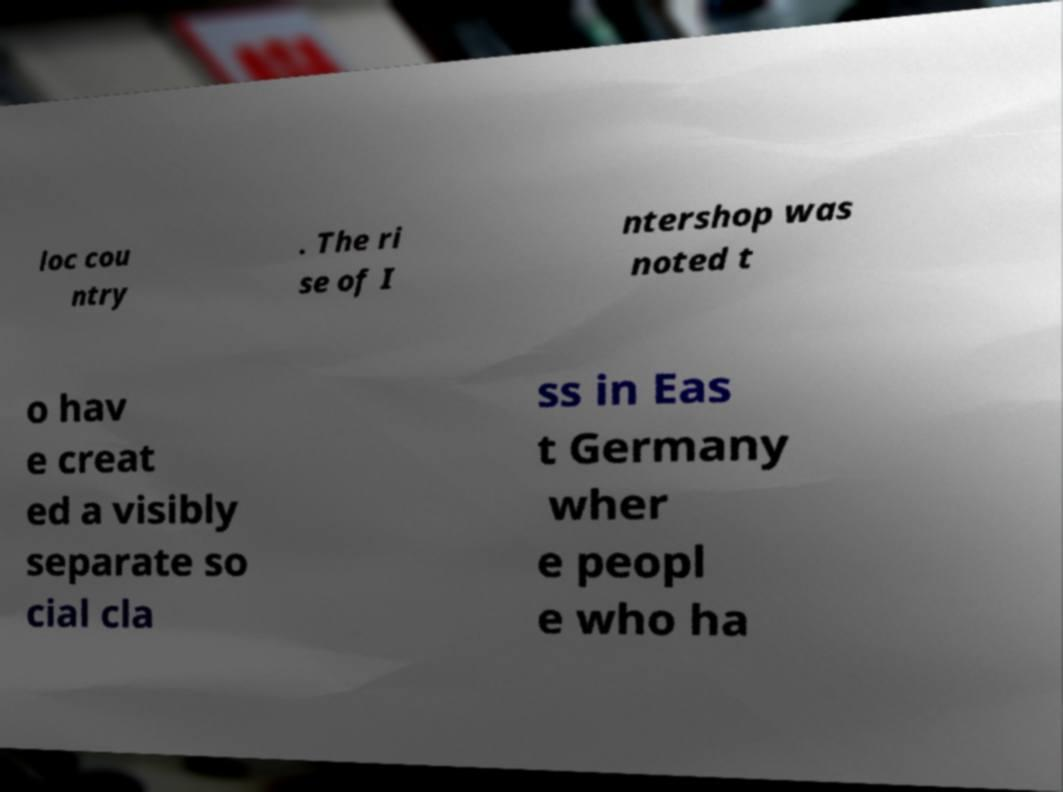Please identify and transcribe the text found in this image. loc cou ntry . The ri se of I ntershop was noted t o hav e creat ed a visibly separate so cial cla ss in Eas t Germany wher e peopl e who ha 